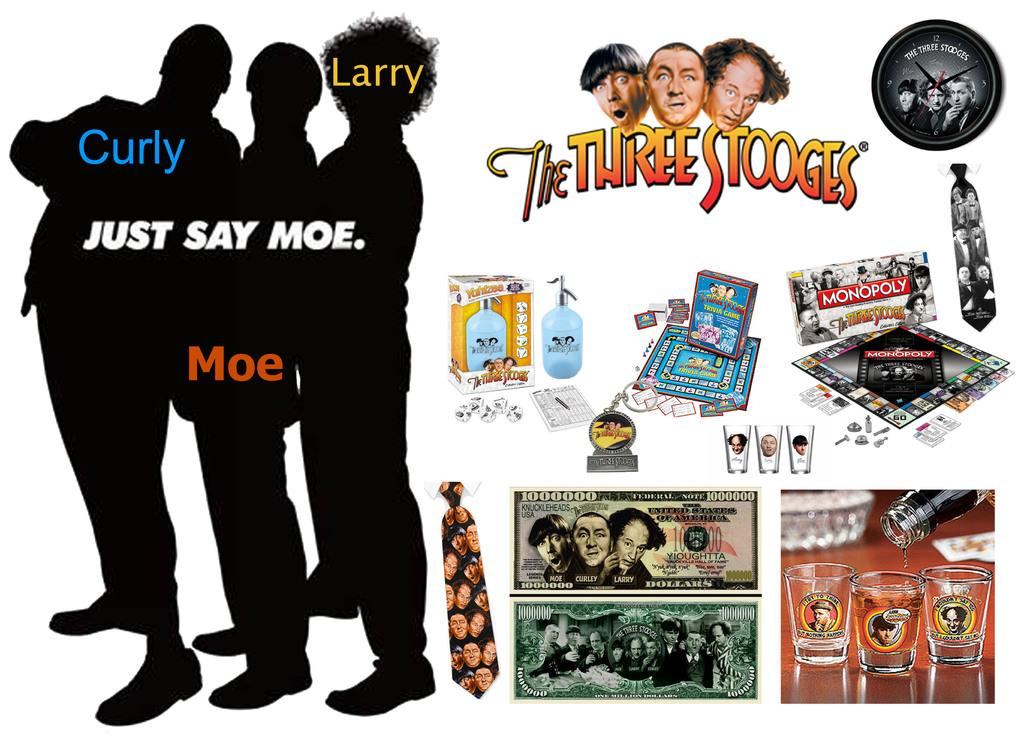<image>
Provide a brief description of the given image. A poster shows the Three Stooges and a few shot glasses on it 